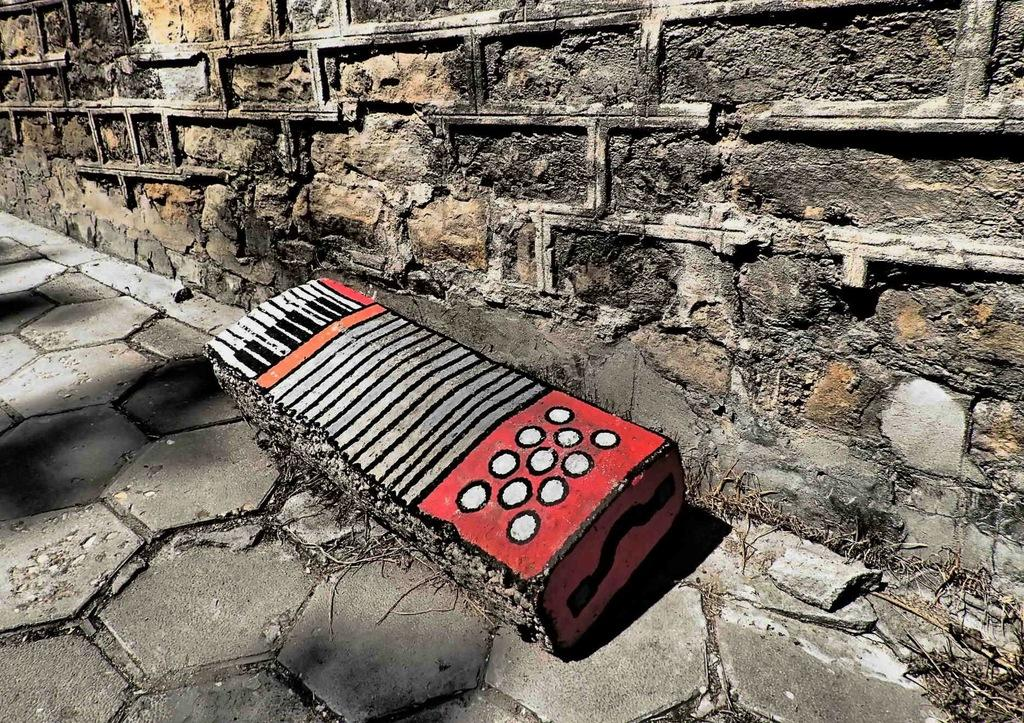What is depicted on the rock in the image? There is a painting on a rock in the image. What can be seen in the background of the image? There is a wall in the background of the image. What type of division can be seen in the image? There is no division present in the image; it features a painting on a rock and a wall in the background. How does the fog affect the visibility in the image? There is no fog present in the image, so its effect on visibility cannot be determined. 